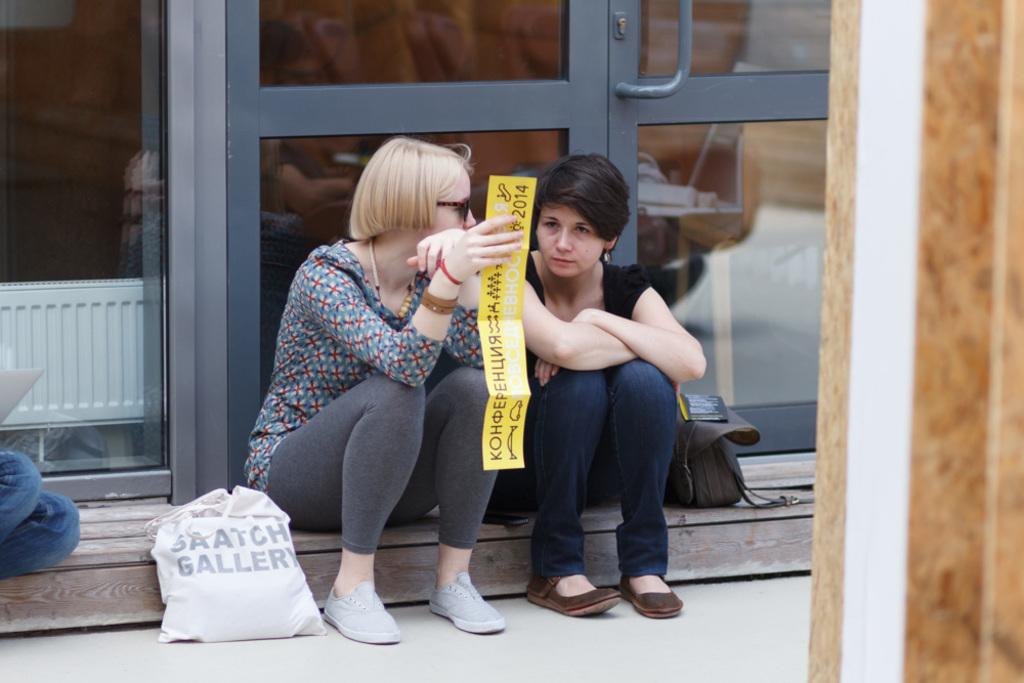How many people are sitting in the image? There are two persons sitting in the image. What are the persons holding in the image? The persons are holding posters. What else can be seen in the image besides the persons and posters? There are bags visible in the image. Can you describe the location of the doors in the image? There are doors in the image, but their exact location is not specified. What part of a person's body is visible in the image? The legs of a person are visible. What is on the right side of the image? There is a wall on the right side of the image. What type of lipstick is the queen wearing in the image? There is no queen or lipstick present in the image. Is there a desk visible in the image? No, there is no desk visible in the image. 